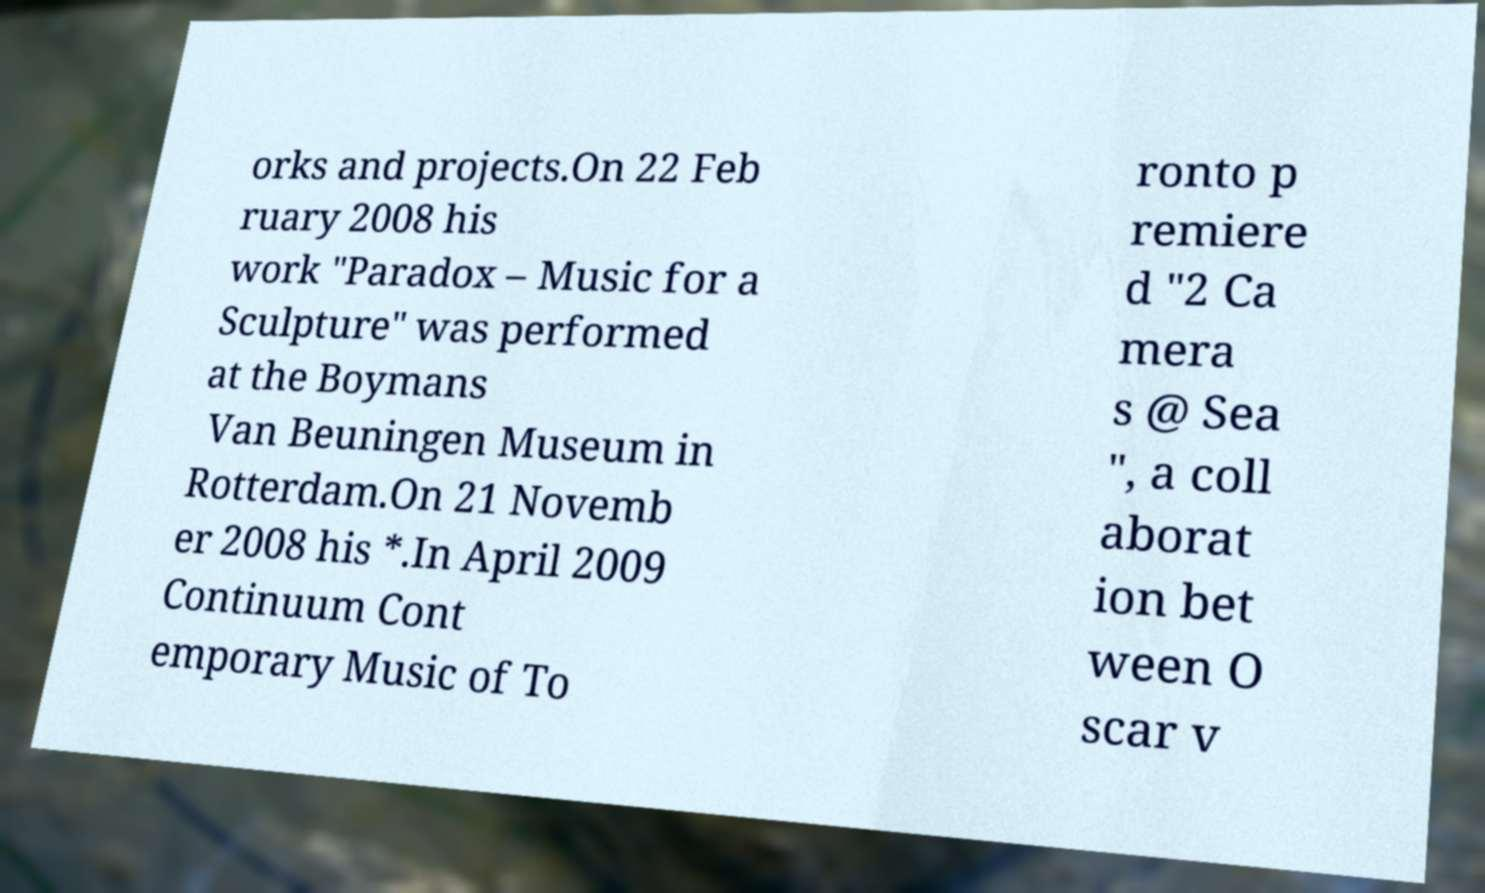Please identify and transcribe the text found in this image. orks and projects.On 22 Feb ruary 2008 his work "Paradox – Music for a Sculpture" was performed at the Boymans Van Beuningen Museum in Rotterdam.On 21 Novemb er 2008 his *.In April 2009 Continuum Cont emporary Music of To ronto p remiere d "2 Ca mera s @ Sea ", a coll aborat ion bet ween O scar v 